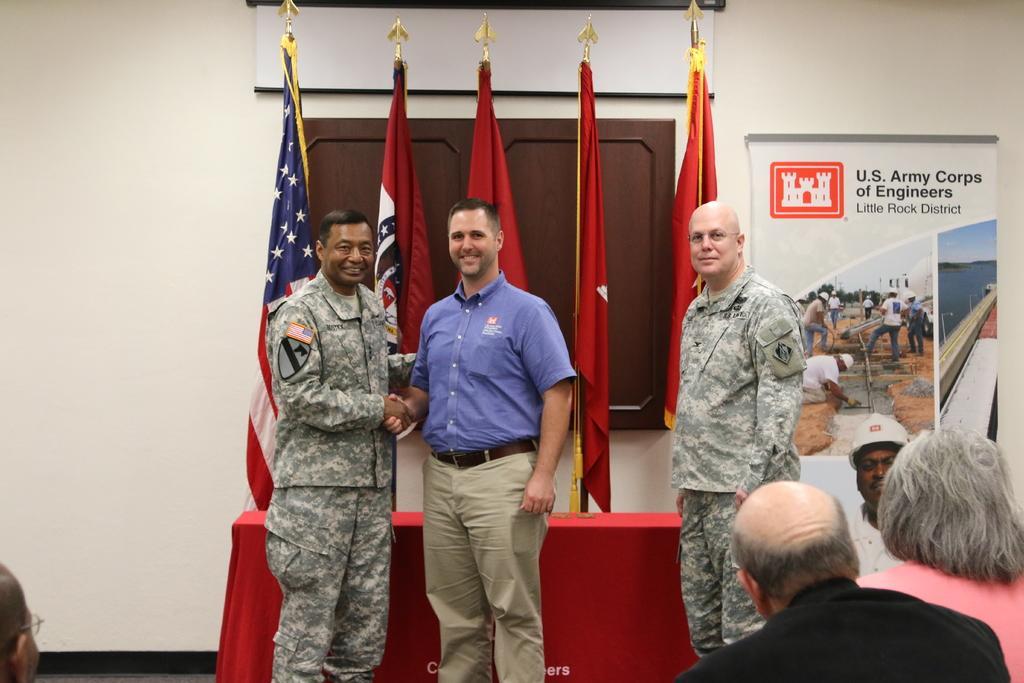Could you give a brief overview of what you see in this image? In this image we can see some persons, three people were standing and remaining people were sitting, there are some flags, in the background there is a wall and on the wall there is a projector with some text. 